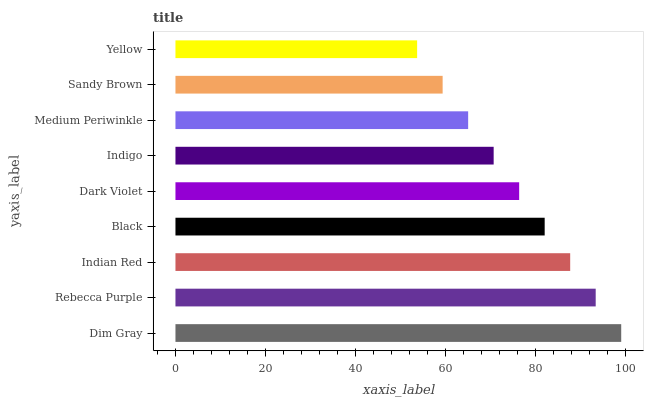Is Yellow the minimum?
Answer yes or no. Yes. Is Dim Gray the maximum?
Answer yes or no. Yes. Is Rebecca Purple the minimum?
Answer yes or no. No. Is Rebecca Purple the maximum?
Answer yes or no. No. Is Dim Gray greater than Rebecca Purple?
Answer yes or no. Yes. Is Rebecca Purple less than Dim Gray?
Answer yes or no. Yes. Is Rebecca Purple greater than Dim Gray?
Answer yes or no. No. Is Dim Gray less than Rebecca Purple?
Answer yes or no. No. Is Dark Violet the high median?
Answer yes or no. Yes. Is Dark Violet the low median?
Answer yes or no. Yes. Is Rebecca Purple the high median?
Answer yes or no. No. Is Indigo the low median?
Answer yes or no. No. 